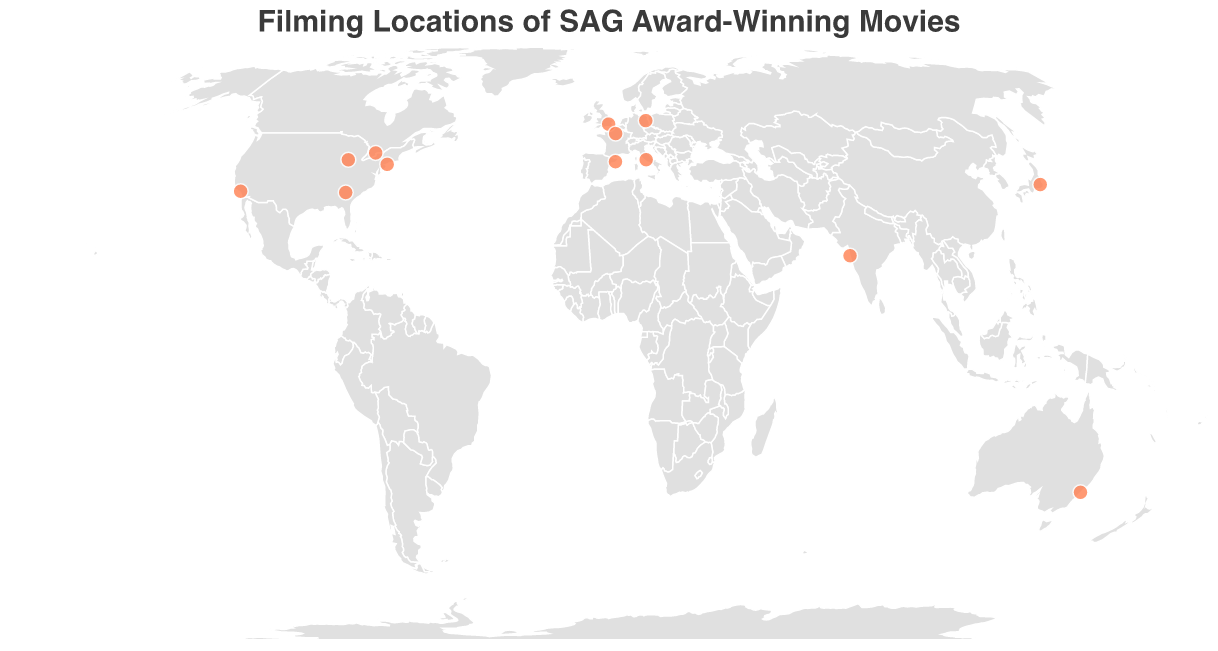What is the title of the figure? The title is usually found at the top center of a plot. Here, the title is defined to clearly describe the content of the figure.
Answer: Filming Locations of SAG Award-Winning Movies How many SAG Award-winning movies have filming locations marked on the map? Each circle on the map represents a filming location of a SAG Award-winning movie. You can count the circles to determine the number of movies.
Answer: 13 Which locations have had movies that won the SAG Award in 2021? Using the tooltip information, hover over each location to see the movie and the year it won. Identify the movies from 2021 and their respective locations.
Answer: New York City and Chicago Compare the number of SAG Award-winning movies filmed in the USA versus Europe. Count the number of circles representing USA locations (Los Angeles, New York City, Chicago, Atlanta) and then count the ones in Europe (London, Rome, Paris, Berlin, Barcelona).
Answer: USA: 4, Europe: 5 What is the farthest distance between two filming locations on the map? Look at the plot and identify the extremes. Sydney (Australia) and Berlin (Germany), or Sydney and London, seem to be the furthest apart. Use geographical knowledge or tools to confirm this.
Answer: Sydney and Berlin / Sydney and London Which year has the most diversity in filming locations across different continents? Look at the years and tally the locations for each year. The year with the most diverse locations spanning multiple continents is considered the most diverse.
Answer: 2016 (Toronto, Sydney) Name a location in Asia and provide the title of the movie filmed there. Look for a circle in Asia and check the tooltip information for the movie title associated with that location.
Answer: Tokyo, Lost in Translation Which city in the USA has the highest number of SAG Award-winning movies filmed there? Identify all the circles in the USA and count the entries for each city. The city with the highest count has the highest number of SAG Award-winning movies.
Answer: The count appears to be equal, no city has more than 1 movie based on the data provided What is the earliest year a listed movie won a SAG Award? Check the tooltip information for the year associated with each movie and identify the smallest year value.
Answer: 2004 Which movie filmed in Europe won a SAG Award in 2014? Hover over the European cities on the map to see the tooltip information and look for the year 2014.
Answer: The Great Beauty 